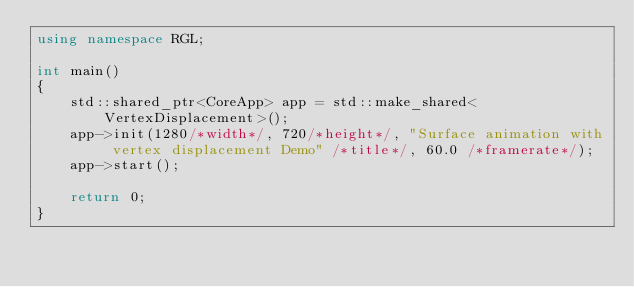Convert code to text. <code><loc_0><loc_0><loc_500><loc_500><_C++_>using namespace RGL;

int main()
{
    std::shared_ptr<CoreApp> app = std::make_shared<VertexDisplacement>();
    app->init(1280/*width*/, 720/*height*/, "Surface animation with vertex displacement Demo" /*title*/, 60.0 /*framerate*/);
    app->start();

    return 0;
}</code> 